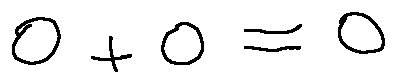Convert formula to latex. <formula><loc_0><loc_0><loc_500><loc_500>0 + 0 = 0</formula> 